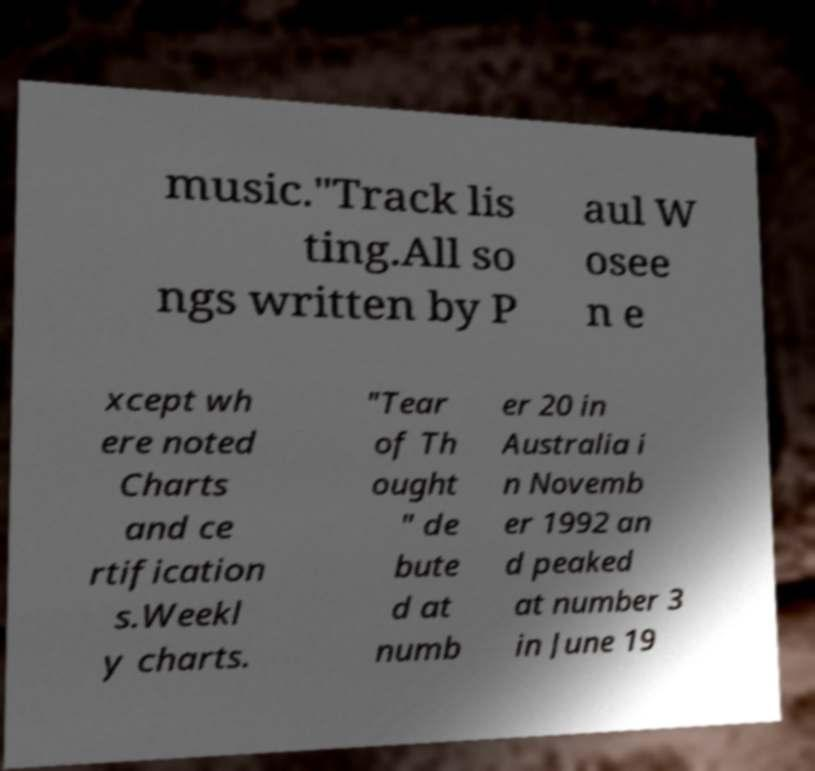For documentation purposes, I need the text within this image transcribed. Could you provide that? music."Track lis ting.All so ngs written by P aul W osee n e xcept wh ere noted Charts and ce rtification s.Weekl y charts. "Tear of Th ought " de bute d at numb er 20 in Australia i n Novemb er 1992 an d peaked at number 3 in June 19 